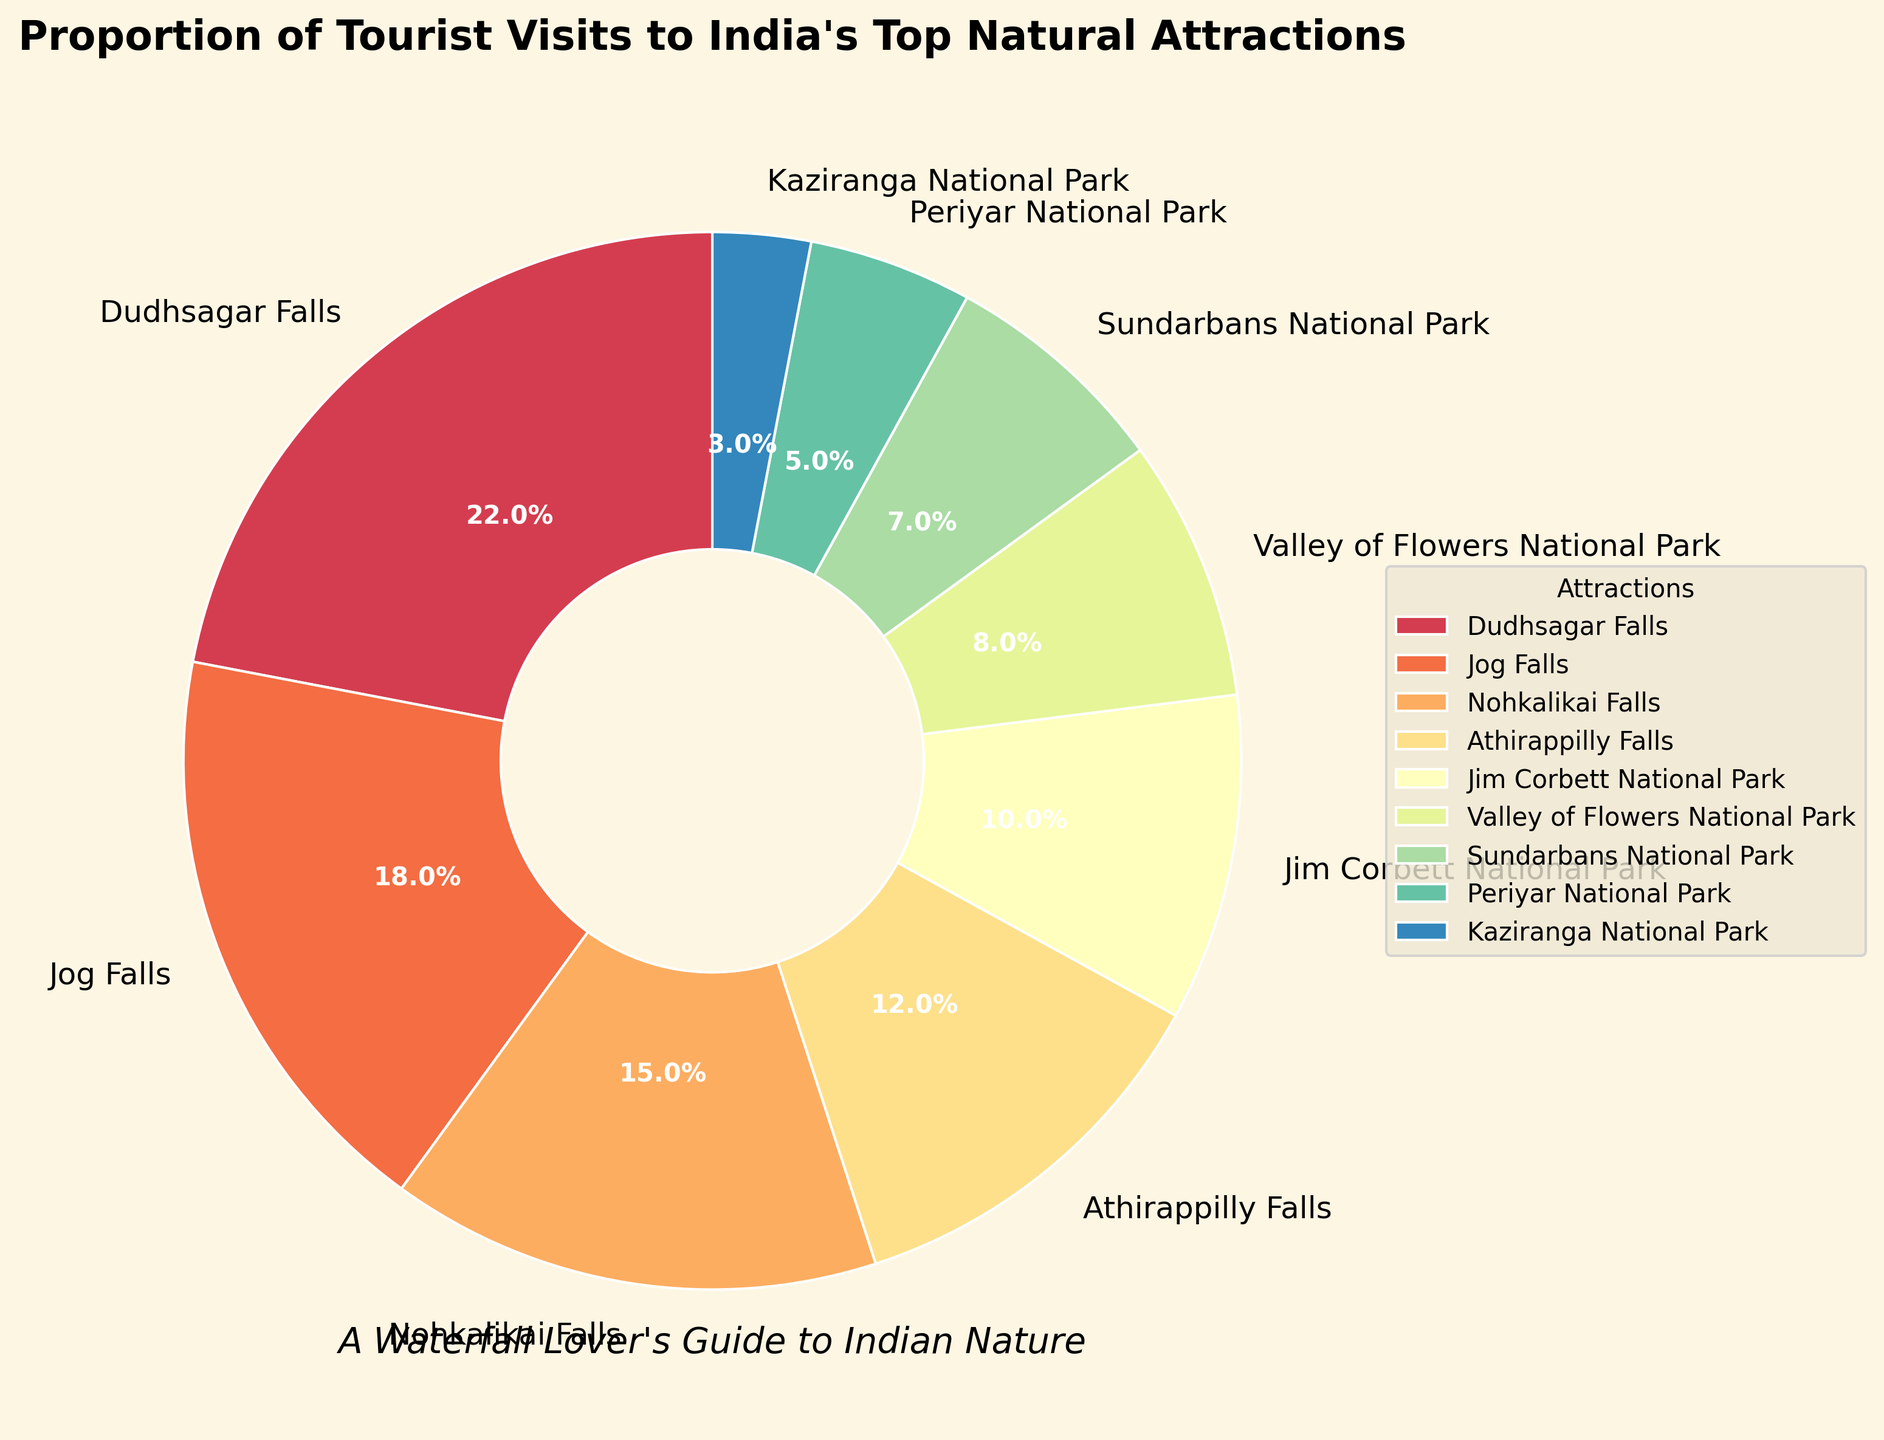What's the highest percentage of tourist visits among the attractions? By looking at the pie chart, the segment representing Dudhsagar Falls is the largest, which indicates the highest percentage. The percentage on it is 22%
Answer: 22% Which attraction has the smallest proportion of tourist visits? By examining the pie chart, we can see that Kaziranga National Park has the smallest section, which represents 3%
Answer: Kaziranga National Park What is the combined percentage of tourist visits to Jog Falls and Nohkalikai Falls? Looking at the pie chart, the percentages for Jog Falls and Nohkalikai Falls are 18% and 15%, respectively. Adding them gives 18 + 15 = 33%
Answer: 33% How much higher is the tourist visit percentage to Dudhsagar Falls compared to Sundarbans National Park? By comparing the pie chart sections, the percentage for Dudhsagar Falls is 22% and for Sundarbans National Park is 7%. The difference is 22 - 7 = 15%
Answer: 15% Are the tourist visit percentages to Periyar National Park and Kaziranga National Park combined greater than Athirappilly Falls alone? From the pie chart, the percentages for Periyar National Park and Kaziranga National Park are 5% and 3%, respectively. Their combined percentage is 5 + 3 = 8%, which is less than Athirappilly Falls' percentage of 12%
Answer: No Which attraction has a higher percentage of tourist visits, Jim Corbett National Park or Valley of Flowers National Park? By observing the pie chart, Jim Corbett National Park has a percentage of 10%, whereas Valley of Flowers National Park has 8%. Thus, Jim Corbett National Park has a higher percentage
Answer: Jim Corbett National Park What is the average percentage of tourist visits across all the listed natural attractions? The percentages for the attractions are as follows: 22, 18, 15, 12, 10, 8, 7, 5, 3. Summing them gives 100. The average is therefore 100/9 ≈ 11.11%
Answer: 11.11% If you visit all the waterfalls listed, what proportion of the total tourist visits do you cover? The waterfalls listed are Dudhsagar Falls, Jog Falls, Nohkalikai Falls, and Athirappilly Falls. Their percentages are 22, 18, 15, and 12. Adding them up gives 22 + 18 + 15 + 12 = 67%
Answer: 67% Which segment of the pie chart has the second largest proportion of tourist visits? By looking at the pie chart, after Dudhsagar Falls, the next largest section represents Jog Falls with 18%
Answer: Jog Falls 